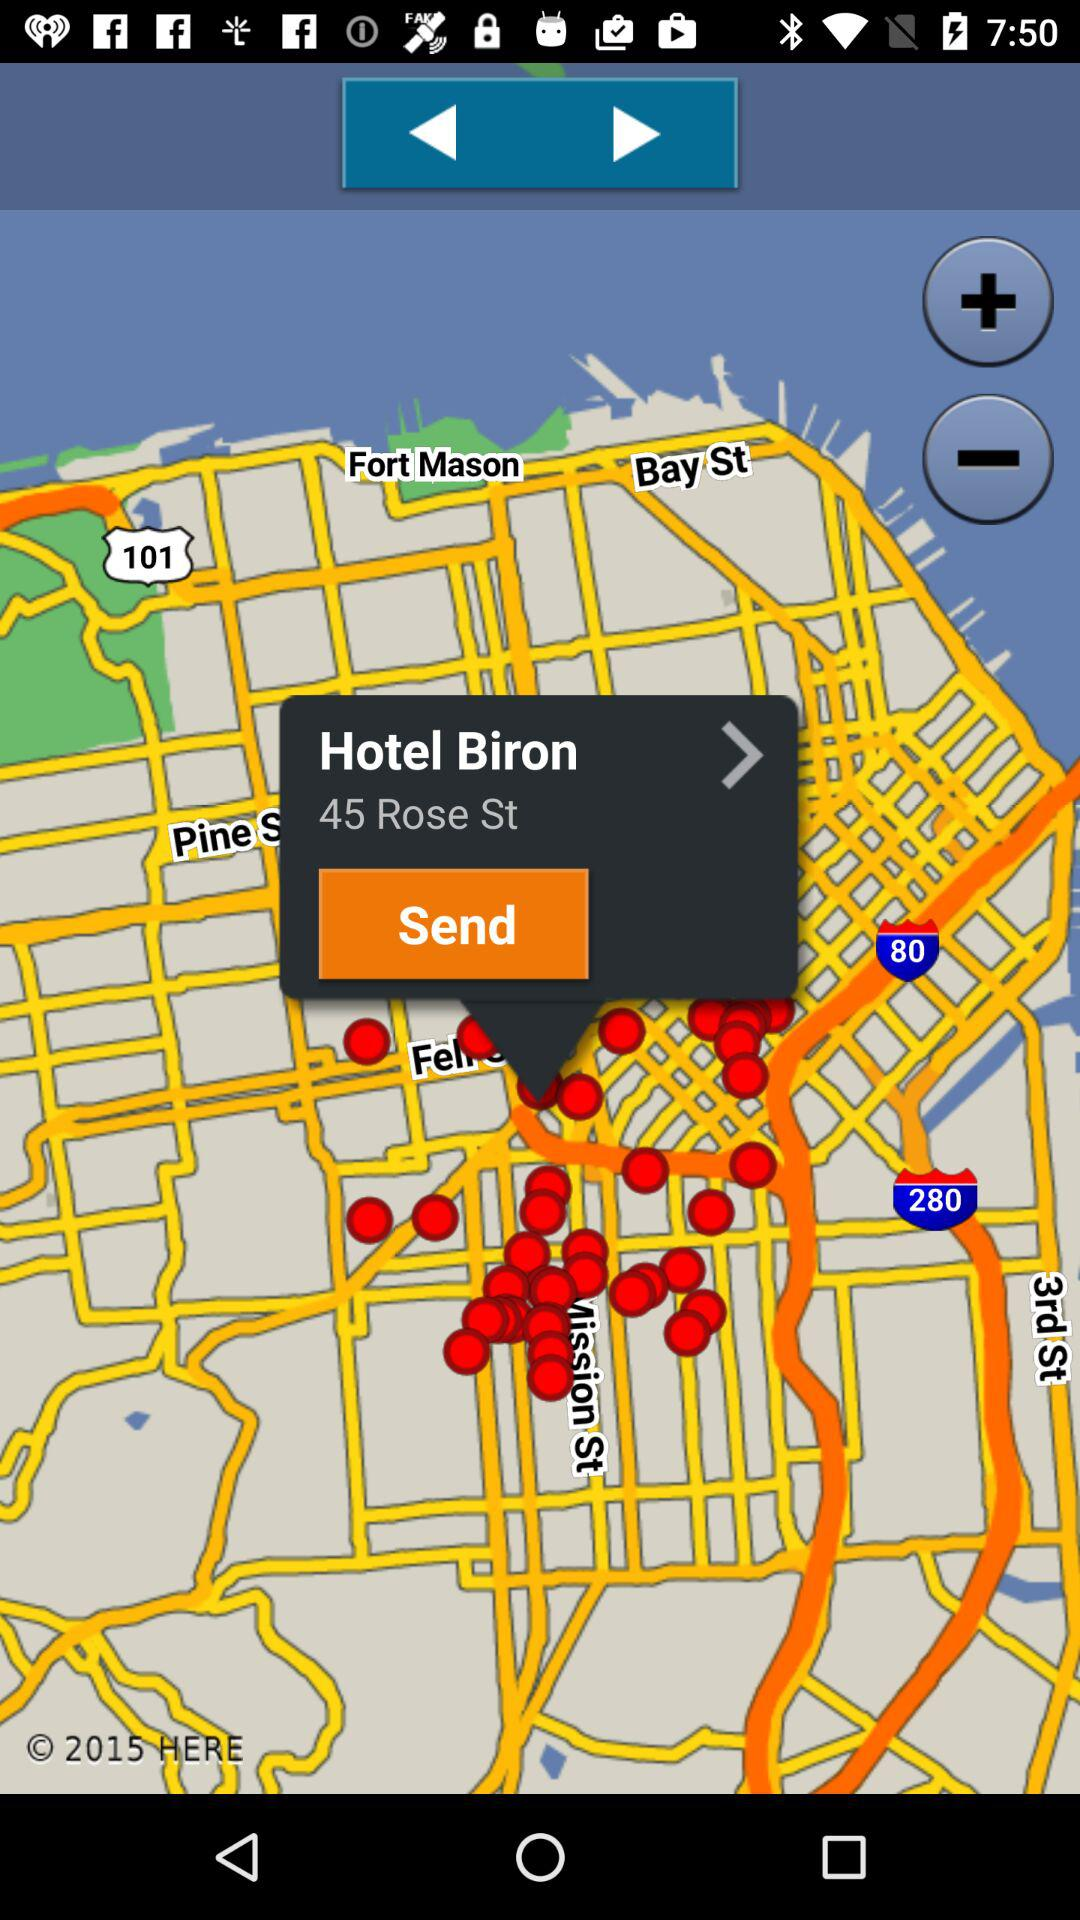What's the hotel name? The hotel name is "Hotel Biron". 